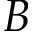<formula> <loc_0><loc_0><loc_500><loc_500>B</formula> 